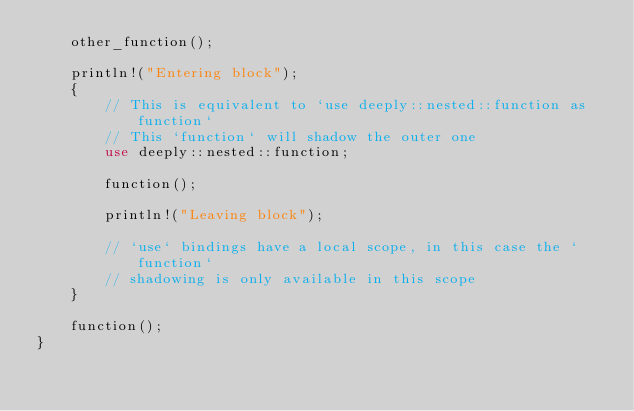<code> <loc_0><loc_0><loc_500><loc_500><_Rust_>    other_function();

    println!("Entering block");
    {
        // This is equivalent to `use deeply::nested::function as function`
        // This `function` will shadow the outer one
        use deeply::nested::function;

        function();

        println!("Leaving block");

        // `use` bindings have a local scope, in this case the `function`
        // shadowing is only available in this scope
    }

    function();
}
</code> 